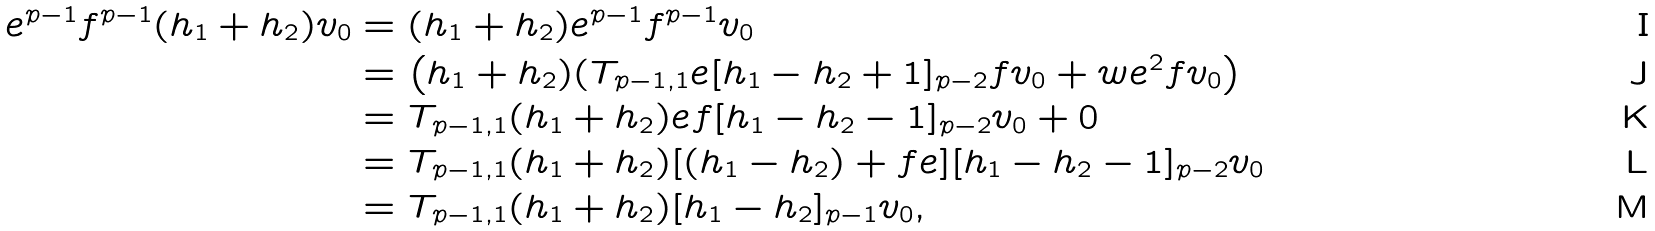<formula> <loc_0><loc_0><loc_500><loc_500>e ^ { p - 1 } f ^ { p - 1 } ( h _ { 1 } + h _ { 2 } ) v _ { 0 } & = ( h _ { 1 } + h _ { 2 } ) e ^ { p - 1 } f ^ { p - 1 } v _ { 0 } \\ & = \left ( h _ { 1 } + h _ { 2 } ) ( T _ { p - 1 , 1 } e [ h _ { 1 } - h _ { 2 } + 1 ] _ { p - 2 } f v _ { 0 } + w e ^ { 2 } f v _ { 0 } \right ) \\ & = T _ { p - 1 , 1 } ( h _ { 1 } + h _ { 2 } ) e f [ h _ { 1 } - h _ { 2 } - 1 ] _ { p - 2 } v _ { 0 } + 0 \\ & = T _ { p - 1 , 1 } ( h _ { 1 } + h _ { 2 } ) [ ( h _ { 1 } - h _ { 2 } ) + f e ] [ h _ { 1 } - h _ { 2 } - 1 ] _ { p - 2 } v _ { 0 } \\ & = T _ { p - 1 , 1 } ( h _ { 1 } + h _ { 2 } ) [ h _ { 1 } - h _ { 2 } ] _ { p - 1 } v _ { 0 } ,</formula> 